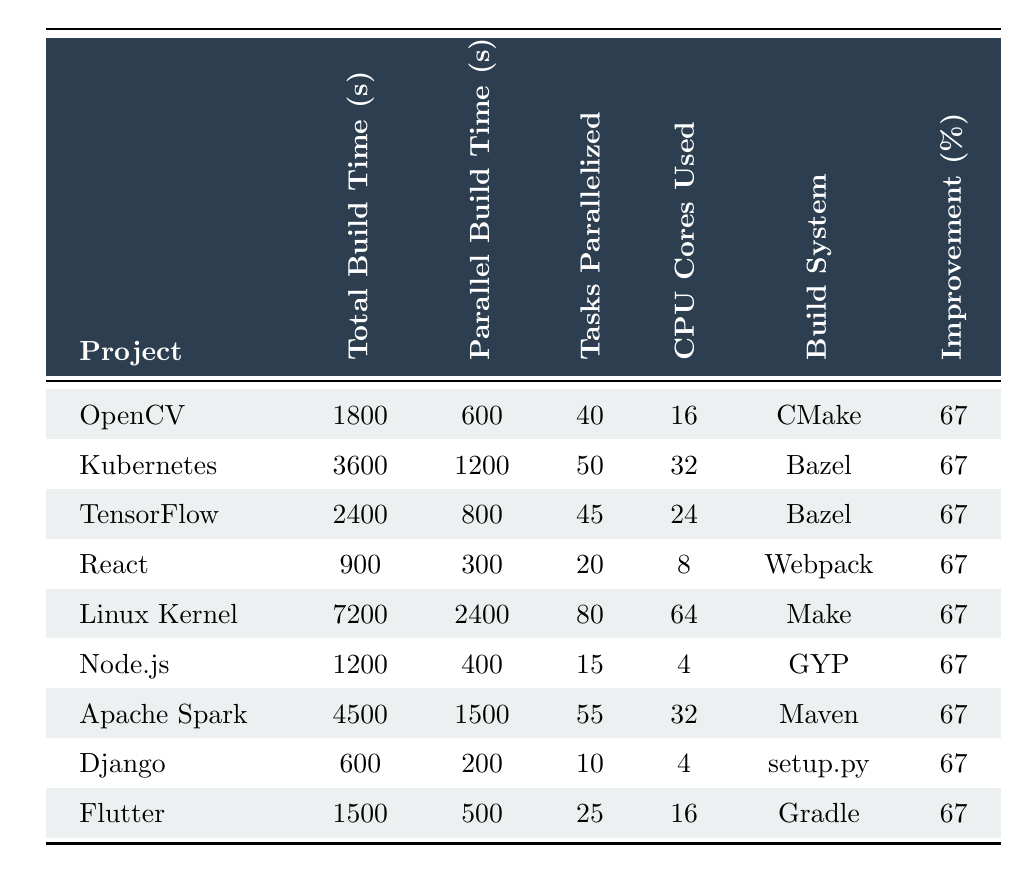What is the total build time for OpenCV? The table lists the total build time for OpenCV as 1800 seconds.
Answer: 1800 How many CPU cores are used in building the Linux Kernel? According to the table, the Linux Kernel uses 64 CPU cores during the build process.
Answer: 64 Which build system is used for Kubernetes? The table indicates that Kubernetes utilizes Bazel as its build system.
Answer: Bazel What is the percentage improvement in build time for TensorFlow? The table shows that TensorFlow achieved a percentage improvement of 67 percent in build time.
Answer: 67 What is the difference in total build time between the Linux Kernel and Apache Spark? The total build time for the Linux Kernel is 7200 seconds and for Apache Spark, it is 4500 seconds. The difference can be calculated as 7200 - 4500 = 2700 seconds.
Answer: 2700 Is Flutter classified as a very large project? The table specifies that Flutter is marked as a very large project as it has the value "true" in that column.
Answer: No What is the average number of tasks parallelized across all projects listed? The tasks parallelized for each project are: 40 (OpenCV), 50 (Kubernetes), 45 (TensorFlow), 20 (React), 80 (Linux Kernel), 15 (Node.js), 55 (Apache Spark), 10 (Django), and 25 (Flutter). The total is 40 + 50 + 45 + 20 + 80 + 15 + 55 + 10 + 25 = 350. Since there are 9 projects, the average is 350 / 9 = approximately 38.89.
Answer: 38.89 How much faster is the parallel build time for React compared to its total build time? The table shows that React has a total build time of 900 seconds and a parallel build time of 300 seconds. The difference is 900 - 300 = 600 seconds, which indicates how much faster it is.
Answer: 600 Which project has the highest number of tasks parallelized? The Linux Kernel has the highest number of tasks parallelized, which is 80, according to the table.
Answer: Linux Kernel What is the average parallel build time across all projects? The parallel build times for the projects are 600 (OpenCV), 1200 (Kubernetes), 800 (TensorFlow), 300 (React), 2400 (Linux Kernel), 400 (Node.js), 1500 (Apache Spark), 200 (Django), and 500 (Flutter). The total is 600 + 1200 + 800 + 300 + 2400 + 400 + 1500 + 200 + 500 = 8000. There are 9 projects, so the average is 8000 / 9 = approximately 888.89 seconds.
Answer: 888.89 